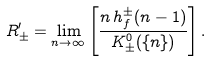Convert formula to latex. <formula><loc_0><loc_0><loc_500><loc_500>R ^ { \prime } _ { \pm } = \lim _ { n \to \infty } \left [ \frac { n \, h _ { f } ^ { \pm } ( n - 1 ) } { K ^ { 0 } _ { \pm } ( \{ n \} ) } \right ] .</formula> 